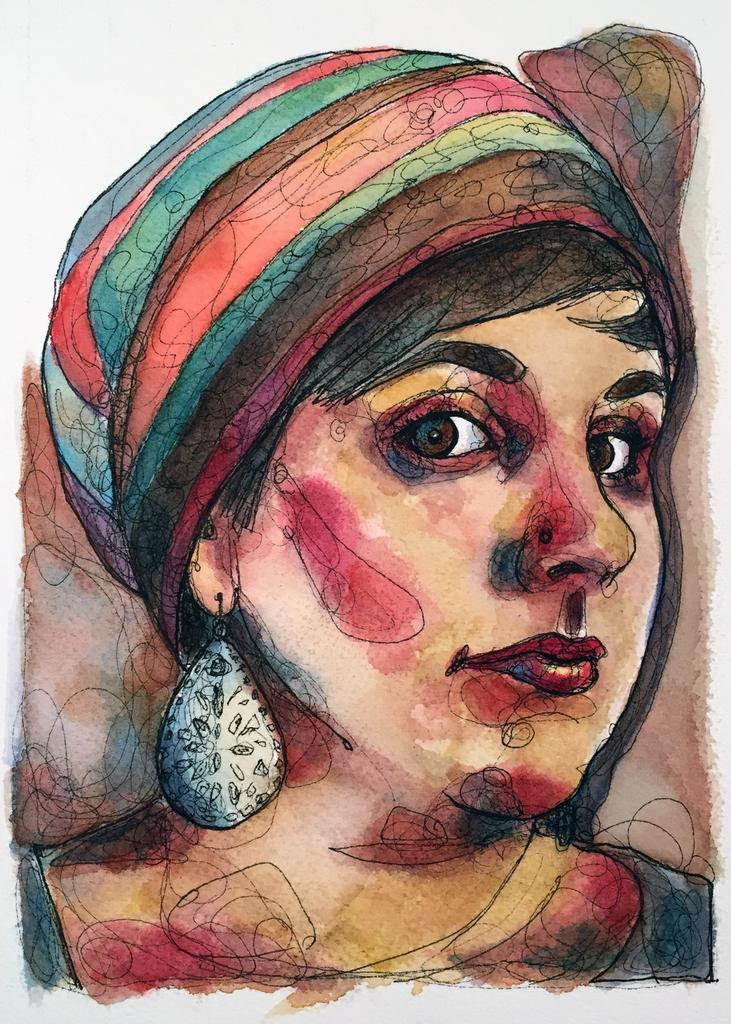What type of artwork is shown in the image? The image is a colorful painting. Who or what is the main subject of the painting? There is a woman depicted in the painting. What word is written on the boat in the painting? There is no boat present in the painting, so no word can be found on it. 